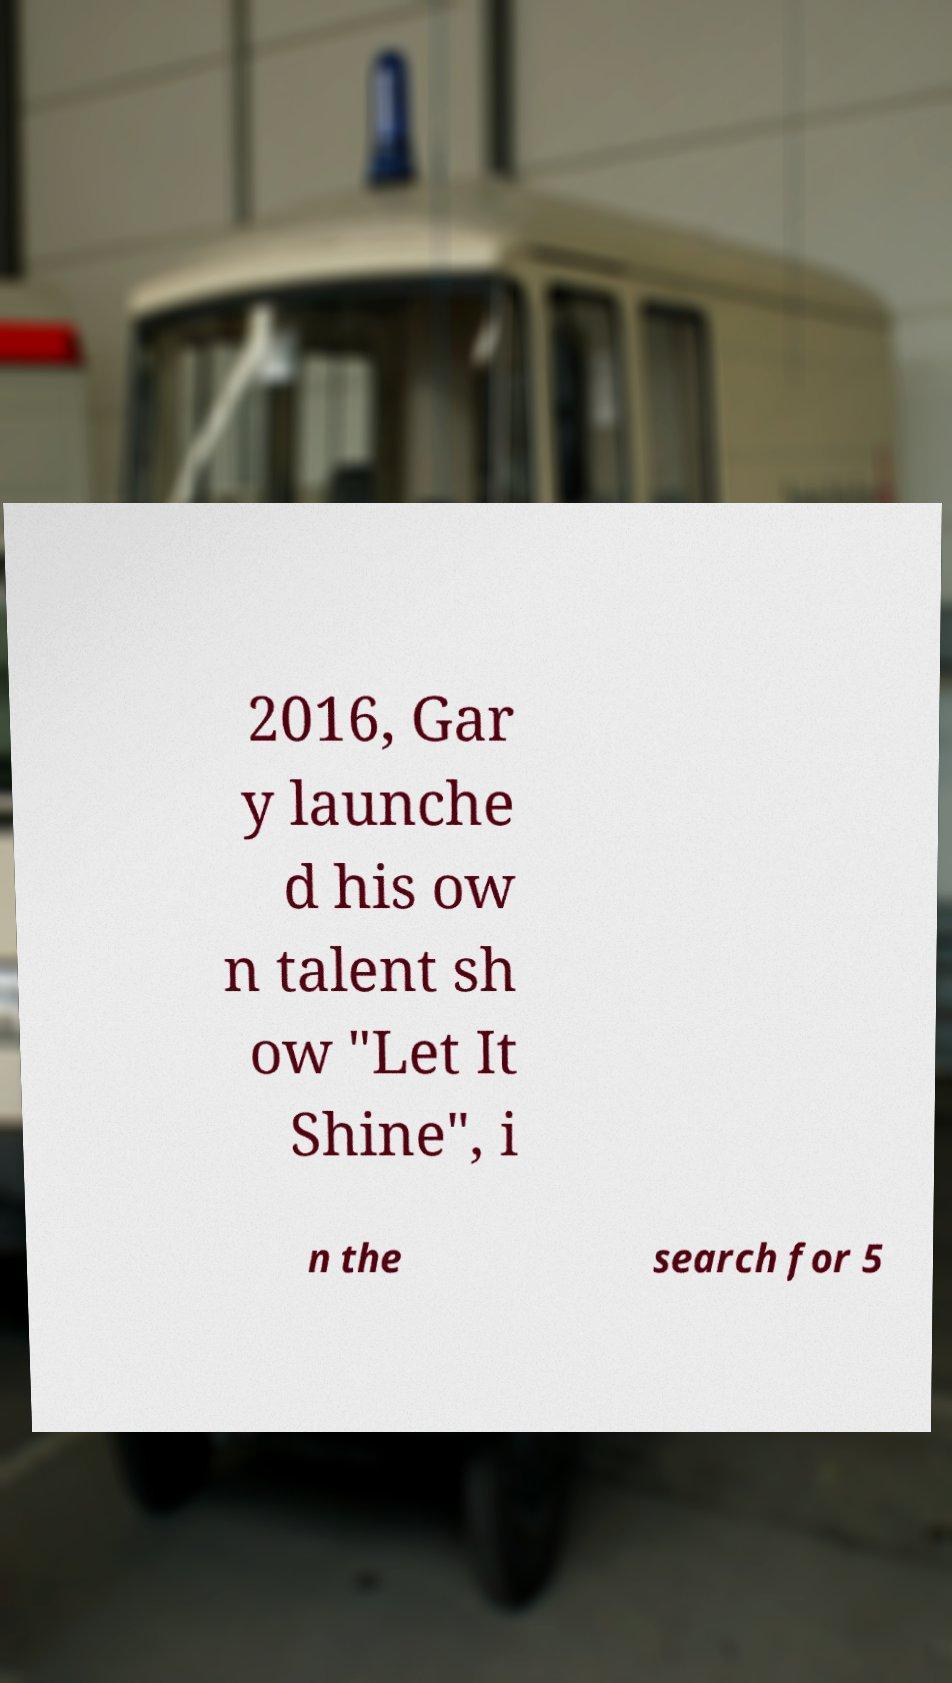What messages or text are displayed in this image? I need them in a readable, typed format. 2016, Gar y launche d his ow n talent sh ow "Let It Shine", i n the search for 5 